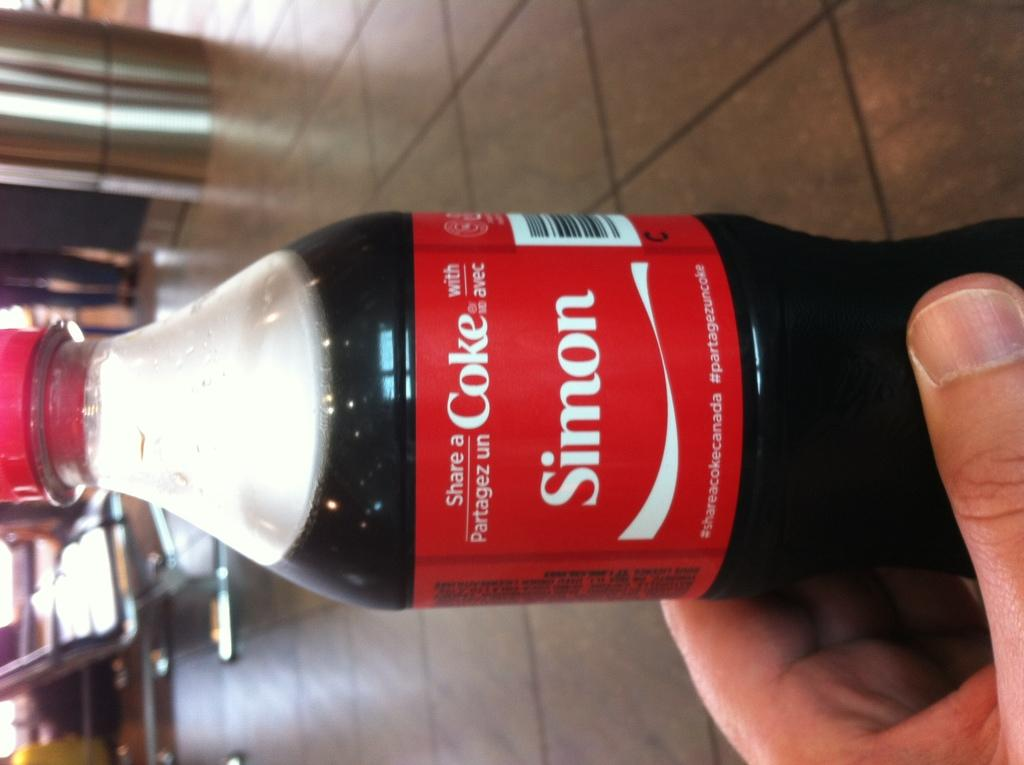<image>
Write a terse but informative summary of the picture. a bottle of coke that says the name 'simon' on the label 